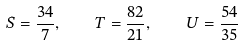<formula> <loc_0><loc_0><loc_500><loc_500>S = \frac { 3 4 } { 7 } , \quad T = \frac { 8 2 } { 2 1 } , \quad U = \frac { 5 4 } { 3 5 }</formula> 